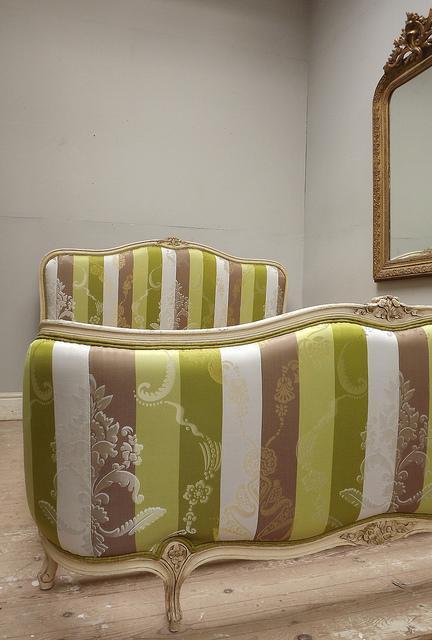How many colors is the furniture?
Give a very brief answer. 4. How many couches are in the photo?
Give a very brief answer. 2. 